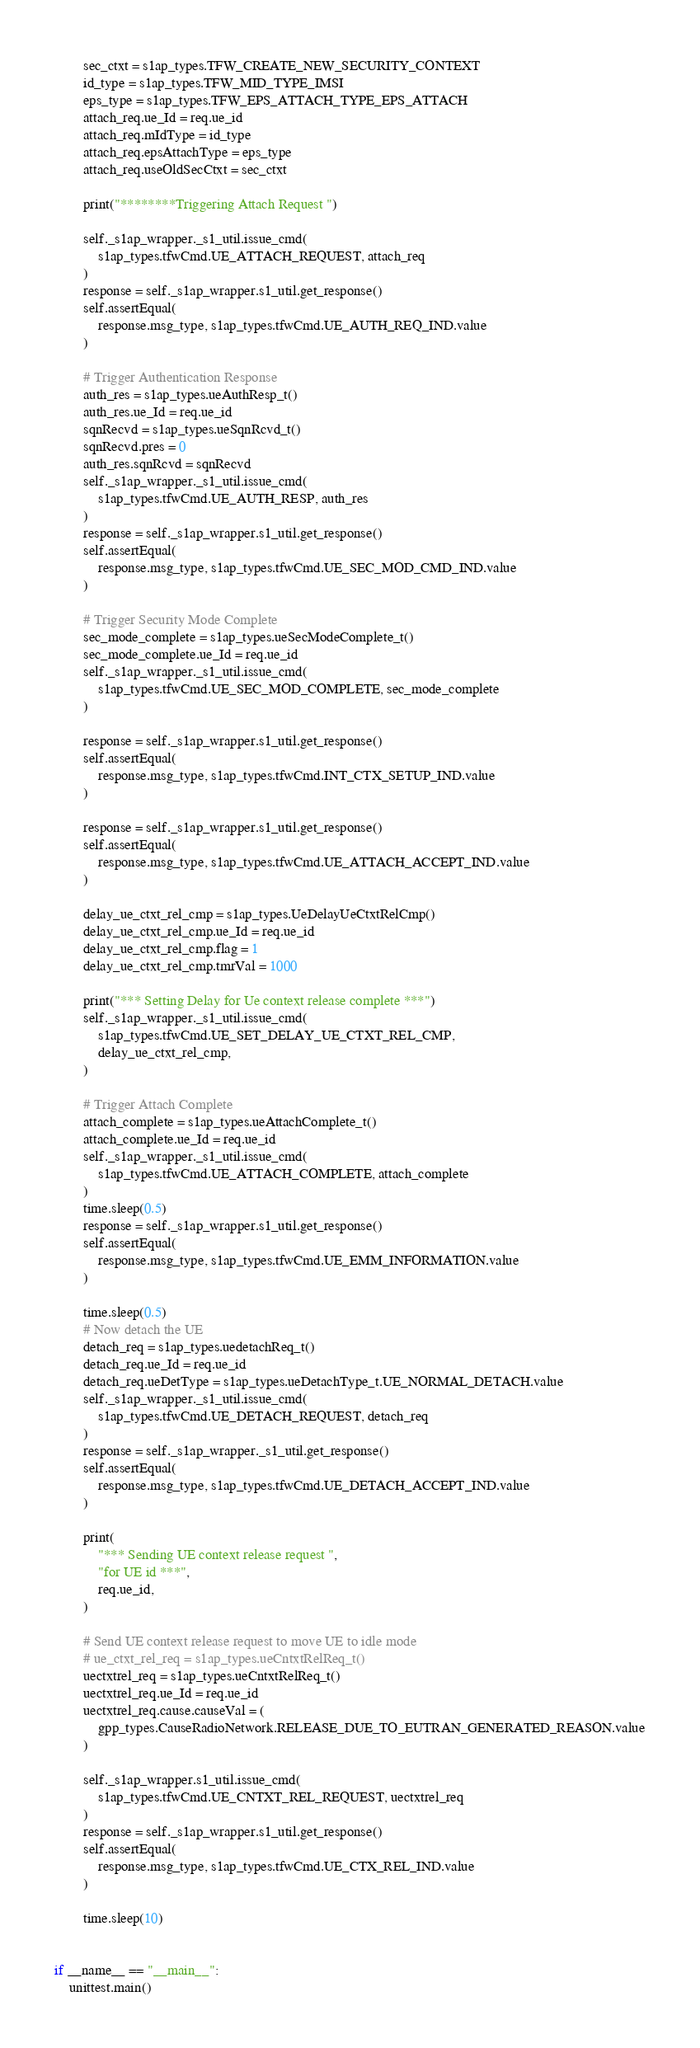<code> <loc_0><loc_0><loc_500><loc_500><_Python_>        sec_ctxt = s1ap_types.TFW_CREATE_NEW_SECURITY_CONTEXT
        id_type = s1ap_types.TFW_MID_TYPE_IMSI
        eps_type = s1ap_types.TFW_EPS_ATTACH_TYPE_EPS_ATTACH
        attach_req.ue_Id = req.ue_id
        attach_req.mIdType = id_type
        attach_req.epsAttachType = eps_type
        attach_req.useOldSecCtxt = sec_ctxt

        print("********Triggering Attach Request ")

        self._s1ap_wrapper._s1_util.issue_cmd(
            s1ap_types.tfwCmd.UE_ATTACH_REQUEST, attach_req
        )
        response = self._s1ap_wrapper.s1_util.get_response()
        self.assertEqual(
            response.msg_type, s1ap_types.tfwCmd.UE_AUTH_REQ_IND.value
        )

        # Trigger Authentication Response
        auth_res = s1ap_types.ueAuthResp_t()
        auth_res.ue_Id = req.ue_id
        sqnRecvd = s1ap_types.ueSqnRcvd_t()
        sqnRecvd.pres = 0
        auth_res.sqnRcvd = sqnRecvd
        self._s1ap_wrapper._s1_util.issue_cmd(
            s1ap_types.tfwCmd.UE_AUTH_RESP, auth_res
        )
        response = self._s1ap_wrapper.s1_util.get_response()
        self.assertEqual(
            response.msg_type, s1ap_types.tfwCmd.UE_SEC_MOD_CMD_IND.value
        )

        # Trigger Security Mode Complete
        sec_mode_complete = s1ap_types.ueSecModeComplete_t()
        sec_mode_complete.ue_Id = req.ue_id
        self._s1ap_wrapper._s1_util.issue_cmd(
            s1ap_types.tfwCmd.UE_SEC_MOD_COMPLETE, sec_mode_complete
        )

        response = self._s1ap_wrapper.s1_util.get_response()
        self.assertEqual(
            response.msg_type, s1ap_types.tfwCmd.INT_CTX_SETUP_IND.value
        )

        response = self._s1ap_wrapper.s1_util.get_response()
        self.assertEqual(
            response.msg_type, s1ap_types.tfwCmd.UE_ATTACH_ACCEPT_IND.value
        )

        delay_ue_ctxt_rel_cmp = s1ap_types.UeDelayUeCtxtRelCmp()
        delay_ue_ctxt_rel_cmp.ue_Id = req.ue_id
        delay_ue_ctxt_rel_cmp.flag = 1
        delay_ue_ctxt_rel_cmp.tmrVal = 1000

        print("*** Setting Delay for Ue context release complete ***")
        self._s1ap_wrapper._s1_util.issue_cmd(
            s1ap_types.tfwCmd.UE_SET_DELAY_UE_CTXT_REL_CMP,
            delay_ue_ctxt_rel_cmp,
        )

        # Trigger Attach Complete
        attach_complete = s1ap_types.ueAttachComplete_t()
        attach_complete.ue_Id = req.ue_id
        self._s1ap_wrapper._s1_util.issue_cmd(
            s1ap_types.tfwCmd.UE_ATTACH_COMPLETE, attach_complete
        )
        time.sleep(0.5)
        response = self._s1ap_wrapper.s1_util.get_response()
        self.assertEqual(
            response.msg_type, s1ap_types.tfwCmd.UE_EMM_INFORMATION.value
        )

        time.sleep(0.5)
        # Now detach the UE
        detach_req = s1ap_types.uedetachReq_t()
        detach_req.ue_Id = req.ue_id
        detach_req.ueDetType = s1ap_types.ueDetachType_t.UE_NORMAL_DETACH.value
        self._s1ap_wrapper._s1_util.issue_cmd(
            s1ap_types.tfwCmd.UE_DETACH_REQUEST, detach_req
        )
        response = self._s1ap_wrapper._s1_util.get_response()
        self.assertEqual(
            response.msg_type, s1ap_types.tfwCmd.UE_DETACH_ACCEPT_IND.value
        )

        print(
            "*** Sending UE context release request ",
            "for UE id ***",
            req.ue_id,
        )

        # Send UE context release request to move UE to idle mode
        # ue_ctxt_rel_req = s1ap_types.ueCntxtRelReq_t()
        uectxtrel_req = s1ap_types.ueCntxtRelReq_t()
        uectxtrel_req.ue_Id = req.ue_id
        uectxtrel_req.cause.causeVal = (
            gpp_types.CauseRadioNetwork.RELEASE_DUE_TO_EUTRAN_GENERATED_REASON.value
        )

        self._s1ap_wrapper.s1_util.issue_cmd(
            s1ap_types.tfwCmd.UE_CNTXT_REL_REQUEST, uectxtrel_req
        )
        response = self._s1ap_wrapper.s1_util.get_response()
        self.assertEqual(
            response.msg_type, s1ap_types.tfwCmd.UE_CTX_REL_IND.value
        )

        time.sleep(10)


if __name__ == "__main__":
    unittest.main()
</code> 